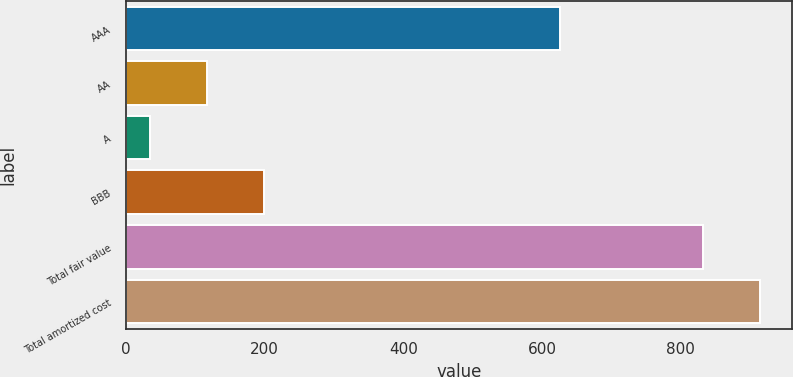<chart> <loc_0><loc_0><loc_500><loc_500><bar_chart><fcel>AAA<fcel>AA<fcel>A<fcel>BBB<fcel>Total fair value<fcel>Total amortized cost<nl><fcel>626<fcel>117.3<fcel>35<fcel>199.6<fcel>832<fcel>914.3<nl></chart> 